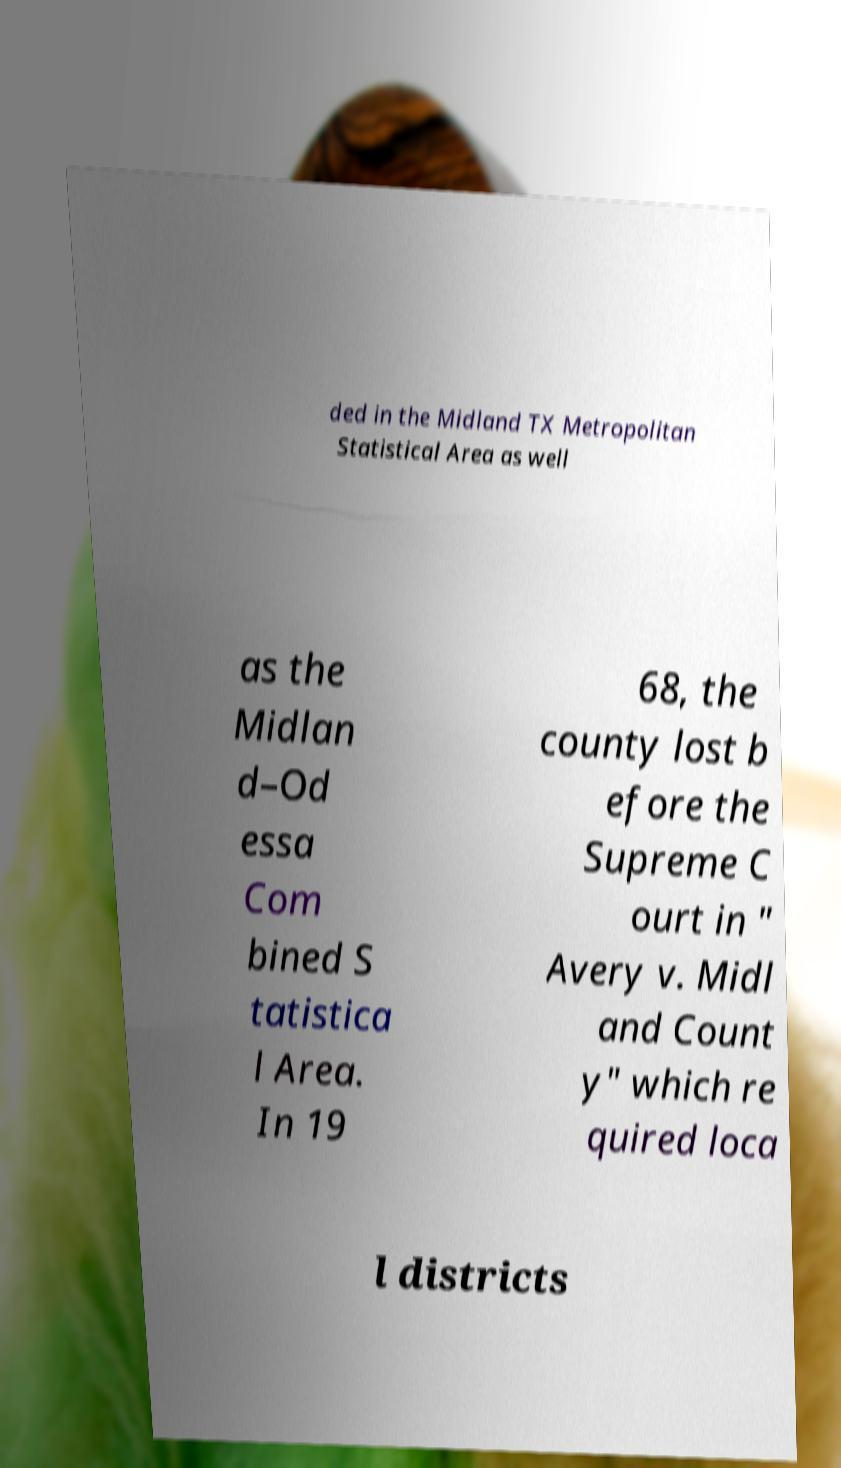I need the written content from this picture converted into text. Can you do that? ded in the Midland TX Metropolitan Statistical Area as well as the Midlan d–Od essa Com bined S tatistica l Area. In 19 68, the county lost b efore the Supreme C ourt in " Avery v. Midl and Count y" which re quired loca l districts 